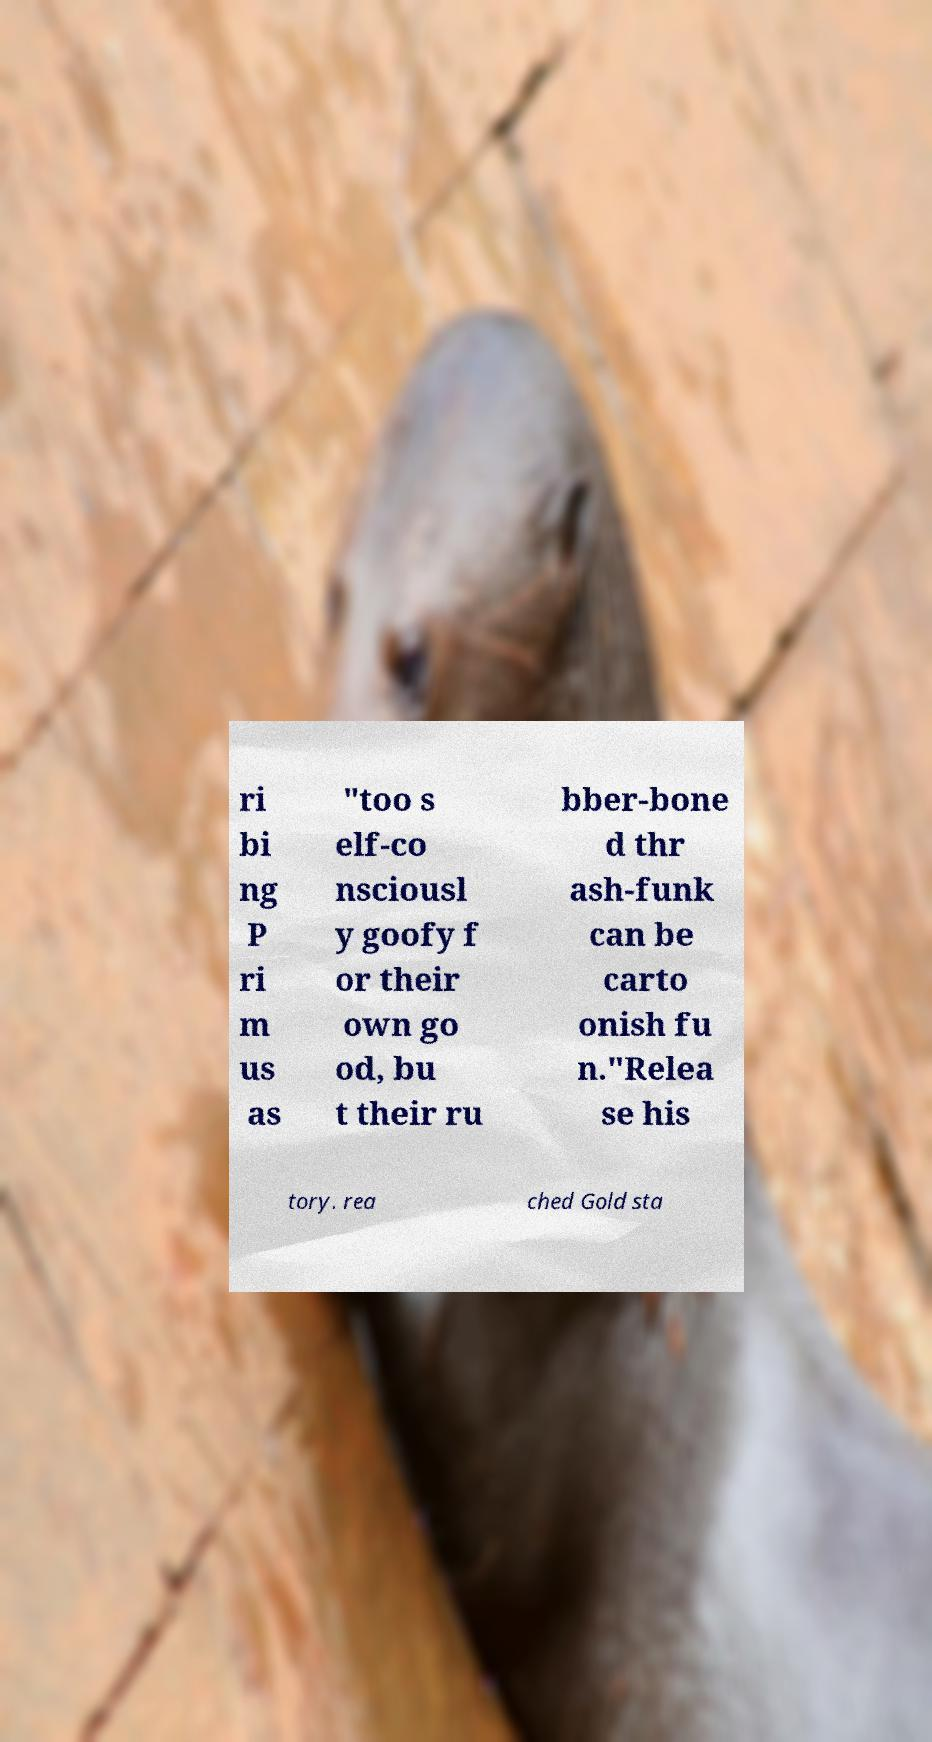I need the written content from this picture converted into text. Can you do that? ri bi ng P ri m us as "too s elf-co nsciousl y goofy f or their own go od, bu t their ru bber-bone d thr ash-funk can be carto onish fu n."Relea se his tory. rea ched Gold sta 